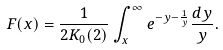<formula> <loc_0><loc_0><loc_500><loc_500>F ( x ) = \frac { 1 } { 2 K _ { 0 } ( 2 ) } \int _ { x } ^ { \infty } e ^ { - y - \frac { 1 } { y } } \frac { d y } { y } .</formula> 